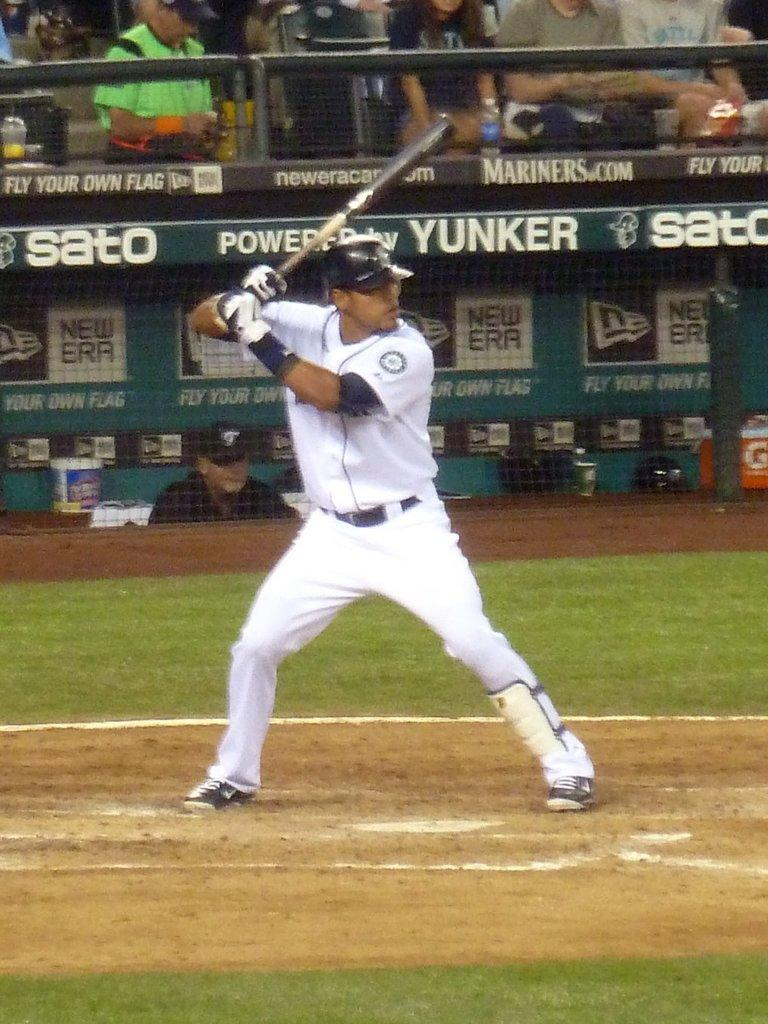<image>
Relay a brief, clear account of the picture shown. player holding bat with signs in dugout behind him for new era and sato 